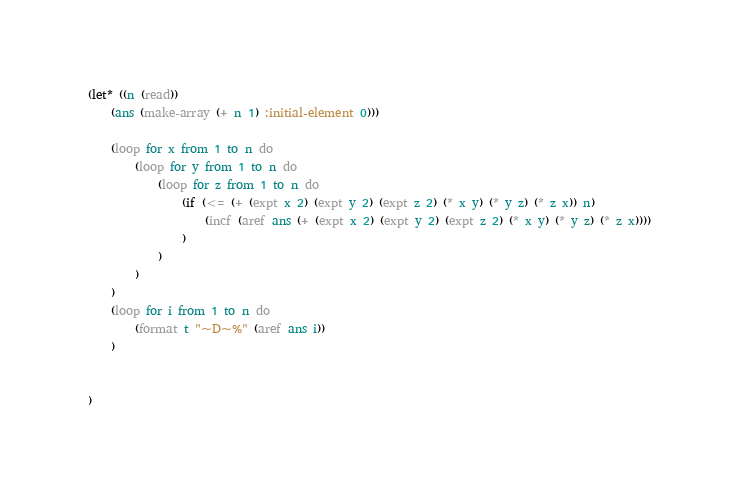Convert code to text. <code><loc_0><loc_0><loc_500><loc_500><_Lisp_>(let* ((n (read))
    (ans (make-array (+ n 1) :initial-element 0)))

    (loop for x from 1 to n do
        (loop for y from 1 to n do
            (loop for z from 1 to n do
                (if (<= (+ (expt x 2) (expt y 2) (expt z 2) (* x y) (* y z) (* z x)) n)
                    (incf (aref ans (+ (expt x 2) (expt y 2) (expt z 2) (* x y) (* y z) (* z x))))
                )
            )
        )
    )
    (loop for i from 1 to n do
        (format t "~D~%" (aref ans i))
    )


)</code> 